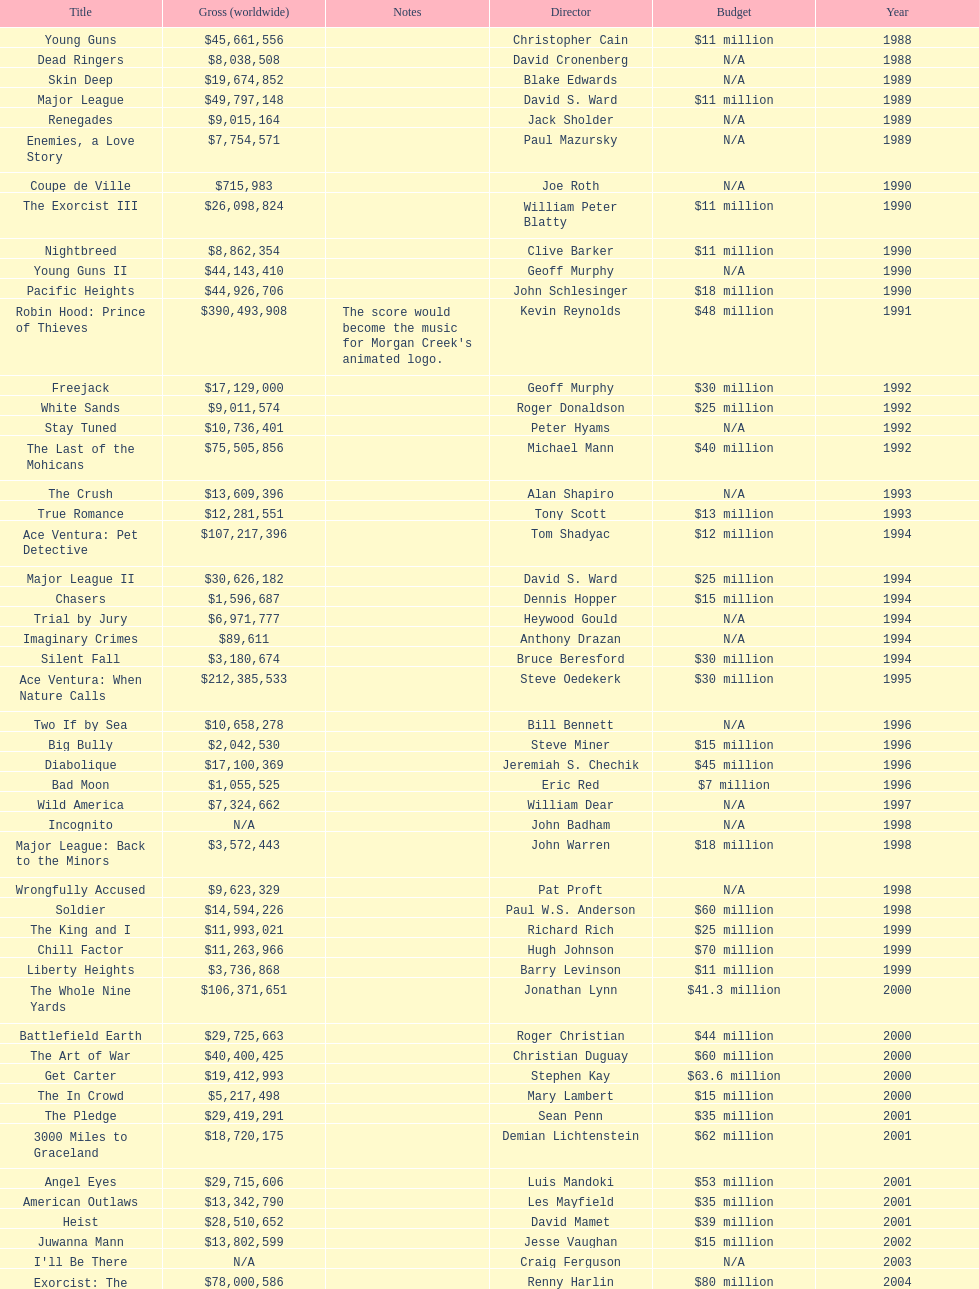Which morgan creek film grossed the most money prior to 1994? Robin Hood: Prince of Thieves. 